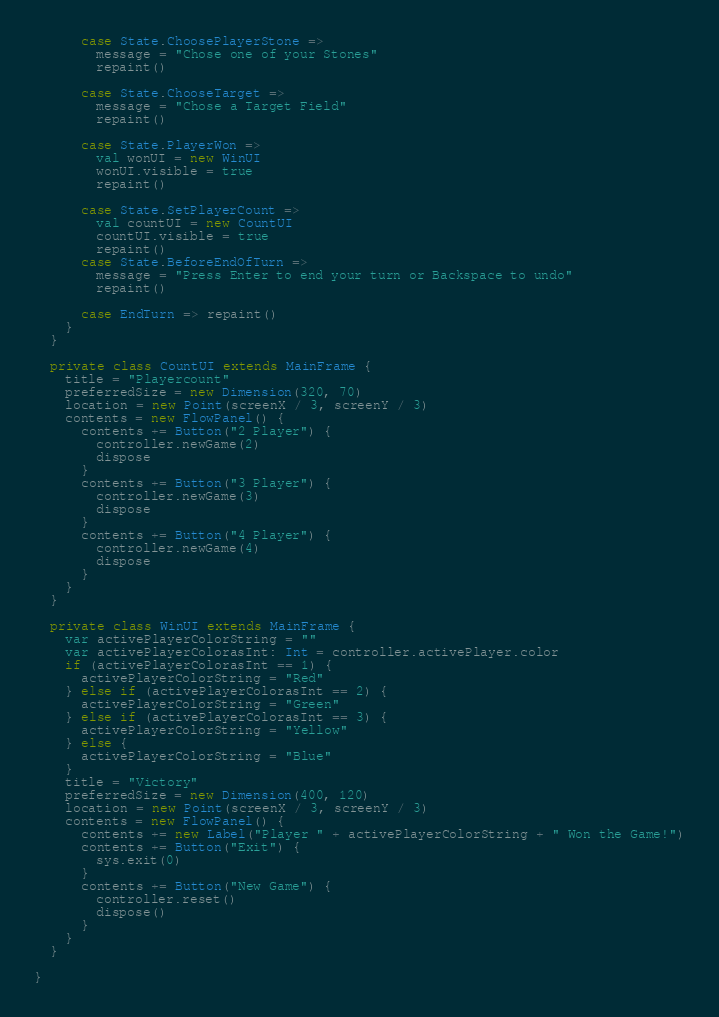Convert code to text. <code><loc_0><loc_0><loc_500><loc_500><_Scala_>
      case State.ChoosePlayerStone =>
        message = "Chose one of your Stones"
        repaint()

      case State.ChooseTarget =>
        message = "Chose a Target Field"
        repaint()

      case State.PlayerWon =>
        val wonUI = new WinUI
        wonUI.visible = true
        repaint()

      case State.SetPlayerCount =>
        val countUI = new CountUI
        countUI.visible = true
        repaint()
      case State.BeforeEndOfTurn =>
        message = "Press Enter to end your turn or Backspace to undo"
        repaint()

      case EndTurn => repaint()
    }
  }

  private class CountUI extends MainFrame {
    title = "Playercount"
    preferredSize = new Dimension(320, 70)
    location = new Point(screenX / 3, screenY / 3)
    contents = new FlowPanel() {
      contents += Button("2 Player") {
        controller.newGame(2)
        dispose
      }
      contents += Button("3 Player") {
        controller.newGame(3)
        dispose
      }
      contents += Button("4 Player") {
        controller.newGame(4)
        dispose
      }
    }
  }

  private class WinUI extends MainFrame {
    var activePlayerColorString = ""
    var activePlayerColorasInt: Int = controller.activePlayer.color
    if (activePlayerColorasInt == 1) {
      activePlayerColorString = "Red"
    } else if (activePlayerColorasInt == 2) {
      activePlayerColorString = "Green"
    } else if (activePlayerColorasInt == 3) {
      activePlayerColorString = "Yellow"
    } else {
      activePlayerColorString = "Blue"
    }
    title = "Victory"
    preferredSize = new Dimension(400, 120)
    location = new Point(screenX / 3, screenY / 3)
    contents = new FlowPanel() {
      contents += new Label("Player " + activePlayerColorString + " Won the Game!")
      contents += Button("Exit") {
        sys.exit(0)
      }
      contents += Button("New Game") {
        controller.reset()
        dispose()
      }
    }
  }

}

</code> 